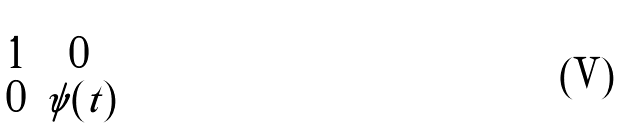Convert formula to latex. <formula><loc_0><loc_0><loc_500><loc_500>\begin{pmatrix} 1 & 0 \\ 0 & \psi ( t ) \end{pmatrix}</formula> 